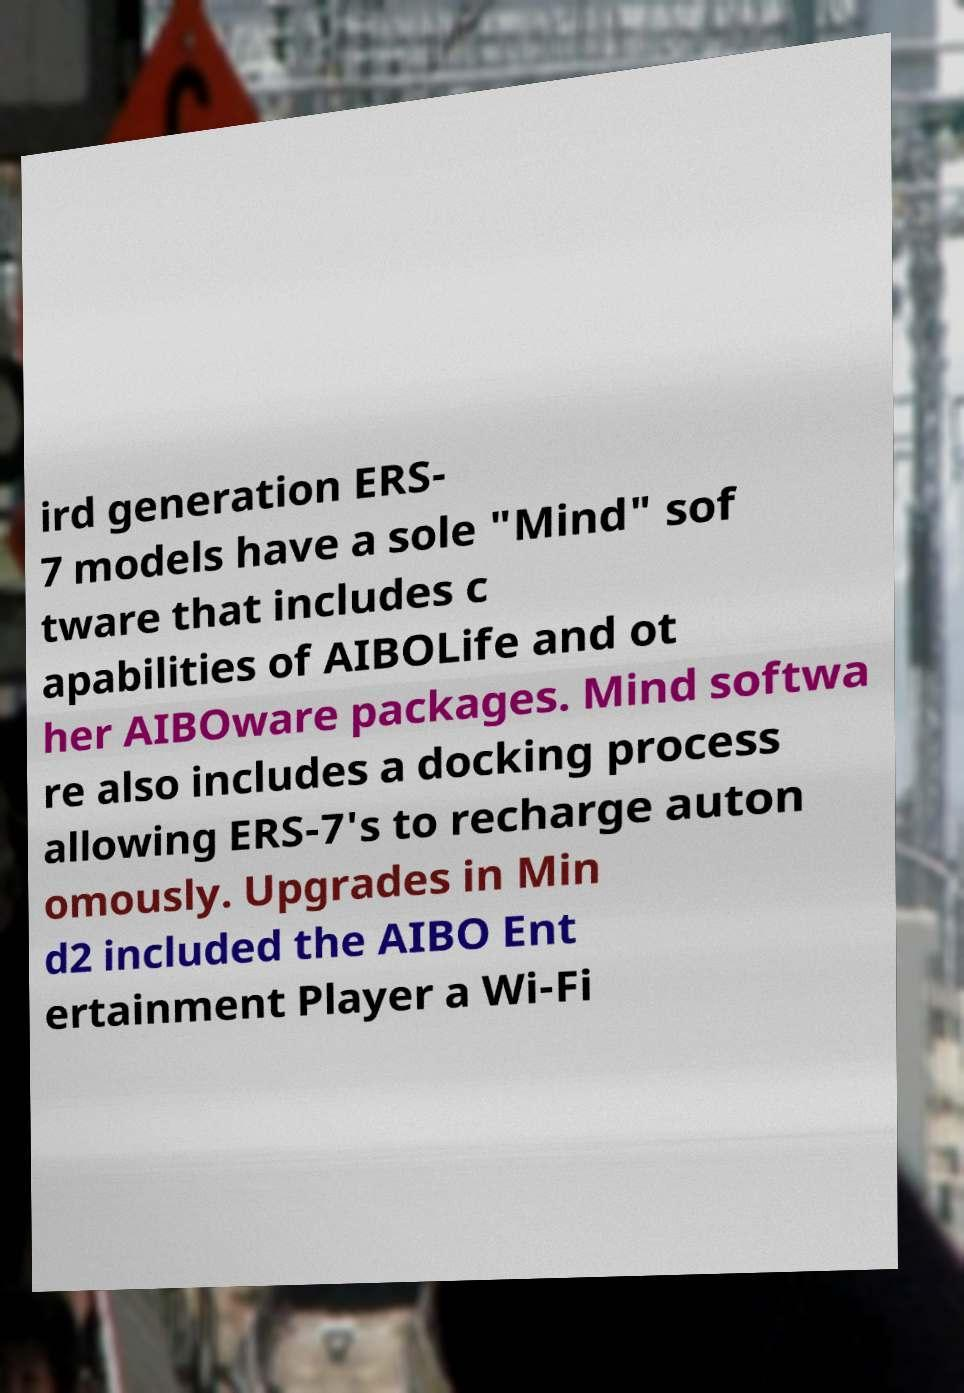For documentation purposes, I need the text within this image transcribed. Could you provide that? ird generation ERS- 7 models have a sole "Mind" sof tware that includes c apabilities of AIBOLife and ot her AIBOware packages. Mind softwa re also includes a docking process allowing ERS-7's to recharge auton omously. Upgrades in Min d2 included the AIBO Ent ertainment Player a Wi-Fi 